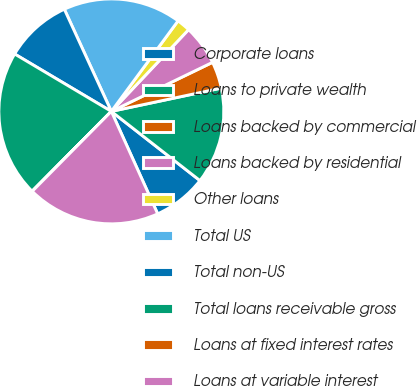Convert chart to OTSL. <chart><loc_0><loc_0><loc_500><loc_500><pie_chart><fcel>Corporate loans<fcel>Loans to private wealth<fcel>Loans backed by commercial<fcel>Loans backed by residential<fcel>Other loans<fcel>Total US<fcel>Total non-US<fcel>Total loans receivable gross<fcel>Loans at fixed interest rates<fcel>Loans at variable interest<nl><fcel>7.69%<fcel>13.87%<fcel>3.86%<fcel>5.77%<fcel>1.94%<fcel>16.97%<fcel>9.61%<fcel>21.09%<fcel>0.02%<fcel>19.17%<nl></chart> 